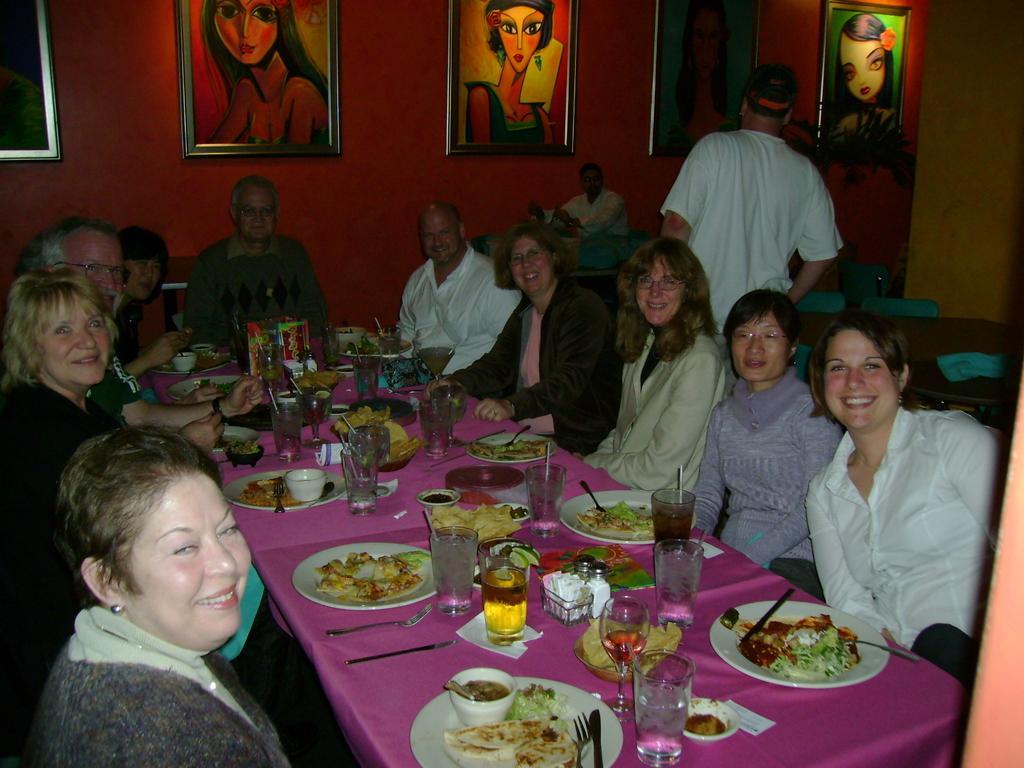Can you describe this image briefly? This image is clicked in a restaurant. There is a table in the middle of the image which consists of glasses, plates ,eatables knife, fork and their people sitting around this table, there are men and women all of them are laughing some of them are with specs and behind them there is a wall on the top which consists of photo frames and there is a man on the right side who is standing, he is wearing white shirt and there are chairs on the right side. 